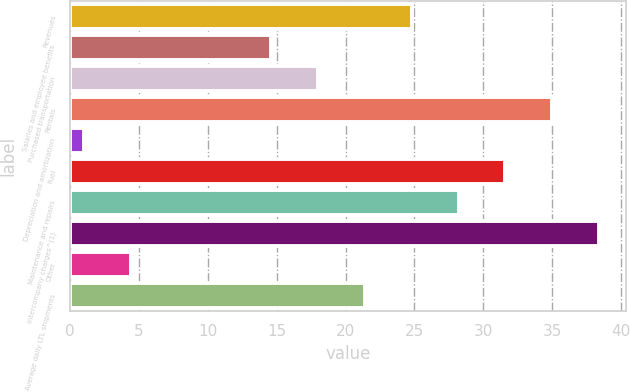Convert chart to OTSL. <chart><loc_0><loc_0><loc_500><loc_500><bar_chart><fcel>Revenues<fcel>Salaries and employee benefits<fcel>Purchased transportation<fcel>Rentals<fcel>Depreciation and amortization<fcel>Fuel<fcel>Maintenance and repairs<fcel>Intercompany charges^(1)<fcel>Other<fcel>Average daily LTL shipments<nl><fcel>24.8<fcel>14.6<fcel>18<fcel>35<fcel>1<fcel>31.6<fcel>28.2<fcel>38.4<fcel>4.4<fcel>21.4<nl></chart> 